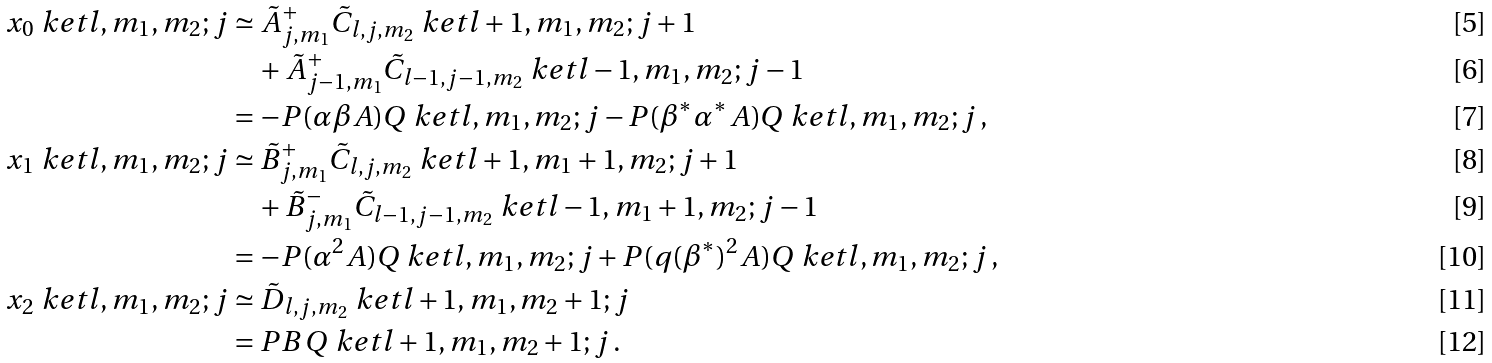Convert formula to latex. <formula><loc_0><loc_0><loc_500><loc_500>x _ { 0 } \ k e t { l , m _ { 1 } , m _ { 2 } ; j } & \simeq \tilde { A } ^ { + } _ { j , m _ { 1 } } \tilde { C } _ { l , j , m _ { 2 } } \ k e t { l + 1 , m _ { 1 } , m _ { 2 } ; j + 1 } \\ & \quad + \tilde { A } ^ { + } _ { j - 1 , m _ { 1 } } \tilde { C } _ { l - 1 , j - 1 , m _ { 2 } } \ k e t { l - 1 , m _ { 1 } , m _ { 2 } ; j - 1 } \\ & = - P ( \alpha \beta A ) Q \ k e t { l , m _ { 1 } , m _ { 2 } ; j } - P ( \beta ^ { * } \alpha ^ { * } A ) Q \ k e t { l , m _ { 1 } , m _ { 2 } ; j } \, , \\ x _ { 1 } \ k e t { l , m _ { 1 } , m _ { 2 } ; j } & \simeq \tilde { B } ^ { + } _ { j , m _ { 1 } } \tilde { C } _ { l , j , m _ { 2 } } \ k e t { l + 1 , m _ { 1 } + 1 , m _ { 2 } ; j + 1 } \\ & \quad + \tilde { B } ^ { - } _ { j , m _ { 1 } } \tilde { C } _ { l - 1 , j - 1 , m _ { 2 } } \ k e t { l - 1 , m _ { 1 } + 1 , m _ { 2 } ; j - 1 } \\ & = - P ( \alpha ^ { 2 } A ) Q \ k e t { l , m _ { 1 } , m _ { 2 } ; j } + P ( q ( \beta ^ { * } ) ^ { 2 } A ) Q \ k e t { l , m _ { 1 } , m _ { 2 } ; j } \, , \\ x _ { 2 } \ k e t { l , m _ { 1 } , m _ { 2 } ; j } & \simeq \tilde { D } _ { l , j , m _ { 2 } } \ k e t { l + 1 , m _ { 1 } , m _ { 2 } + 1 ; j } \\ & = P B \, Q \ k e t { l + 1 , m _ { 1 } , m _ { 2 } + 1 ; j } \, .</formula> 